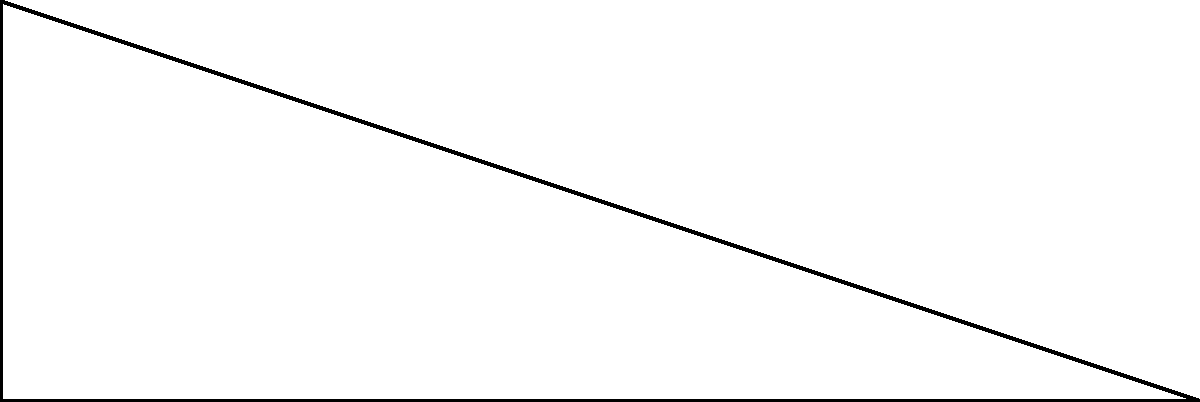You're designing a wheelchair ramp for your child. The building code requires a maximum slope of 1:12 (rise:run). Given a vertical rise of 2 feet and a horizontal run of 6 feet, what is the angle $\theta$ of the ramp in degrees? Round your answer to the nearest degree. To solve this problem, we'll use right triangle trigonometry:

1) First, identify the rise and run:
   Rise (opposite side) = 2 feet
   Run (adjacent side) = 6 feet

2) The tangent of an angle in a right triangle is the ratio of the opposite side to the adjacent side:
   $$\tan(\theta) = \frac{\text{opposite}}{\text{adjacent}} = \frac{\text{rise}}{\text{run}}$$

3) Substitute the values:
   $$\tan(\theta) = \frac{2}{6} = \frac{1}{3}$$

4) To find $\theta$, we need to use the inverse tangent (arctan or $\tan^{-1}$):
   $$\theta = \tan^{-1}(\frac{1}{3})$$

5) Using a calculator or trigonometric tables:
   $$\theta \approx 18.43^\circ$$

6) Rounding to the nearest degree:
   $$\theta \approx 18^\circ$$

7) Check if this meets the building code requirement:
   Slope = rise / run = 2 / 6 = 1 / 3, which is less steep than 1:12, so it's acceptable.
Answer: $18^\circ$ 